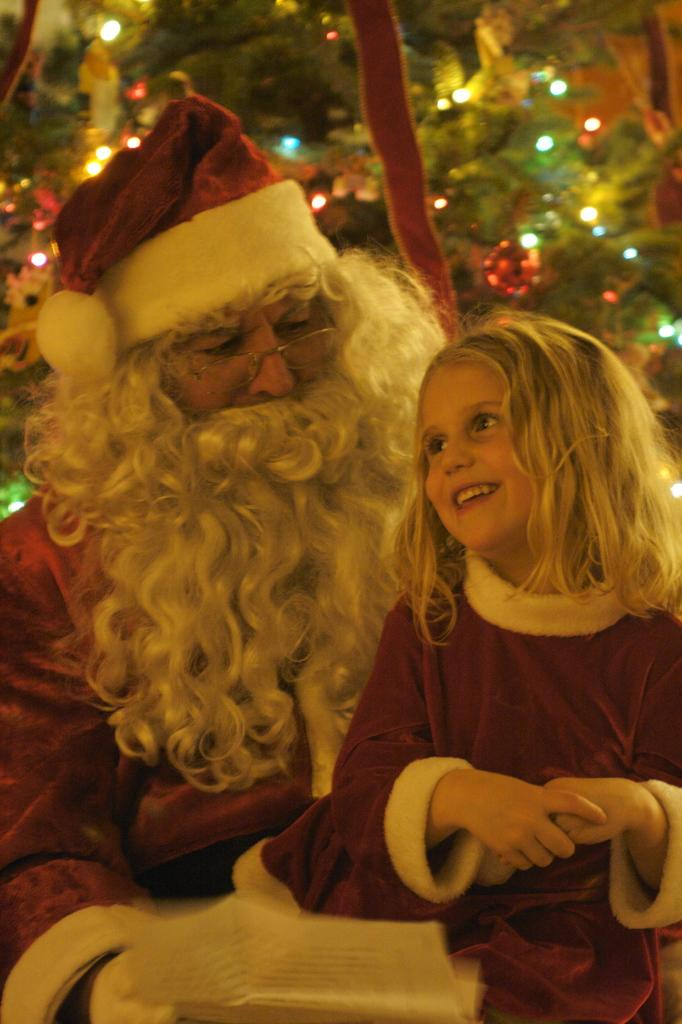Who is present in the image? There is a person and a kid in the image. Where are the person and kid located in the image? They are in the front of the image. What can be seen in the background of the image? There are leaves and lights in the background of the image. What reason does the beast have for being in the image? There is no beast present in the image, so it is not possible to determine a reason for its presence. 